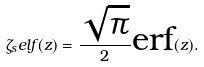Convert formula to latex. <formula><loc_0><loc_0><loc_500><loc_500>\zeta _ { s } e l f ( z ) = \frac { \sqrt { \pi } } { 2 } \text {erf} ( z ) .</formula> 